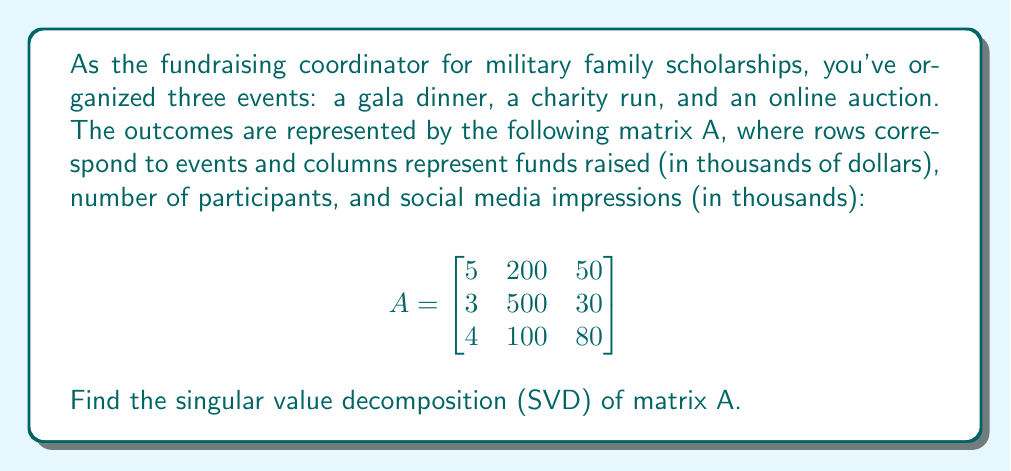Show me your answer to this math problem. To find the singular value decomposition of matrix A, we need to follow these steps:

1) First, calculate $A^TA$:

   $$A^TA = \begin{bmatrix}
   5 & 3 & 4 \\
   200 & 500 & 100 \\
   50 & 30 & 80
   \end{bmatrix} \begin{bmatrix}
   5 & 200 & 50 \\
   3 & 500 & 30 \\
   4 & 100 & 80
   \end{bmatrix} = \begin{bmatrix}
   50 & 2150 & 570 \\
   2150 & 290000 & 17000 \\
   570 & 17000 & 9100
   \end{bmatrix}$$

2) Find the eigenvalues of $A^TA$ by solving the characteristic equation:
   
   $\det(A^TA - \lambda I) = 0$

   This gives us the equation:

   $-\lambda^3 + 299150\lambda^2 - 1.30205 \times 10^9\lambda + 8.41 \times 10^{11} = 0$

3) Solving this equation (using a computer algebra system), we get the eigenvalues:
   
   $\lambda_1 \approx 290050.8$
   $\lambda_2 \approx 9098.2$
   $\lambda_3 \approx 1.0$

4) The singular values are the square roots of these eigenvalues:
   
   $\sigma_1 \approx 538.56$
   $\sigma_2 \approx 95.38$
   $\sigma_3 \approx 1.00$

5) To find the right singular vectors, we solve $(A^TA - \lambda_i I)v_i = 0$ for each $\lambda_i$. After normalization, we get:

   $v_1 \approx [0.0074, 0.9999, 0.0059]^T$
   $v_2 \approx [-0.0757, -0.0031, 0.9971]^T$
   $v_3 \approx [0.9971, -0.0075, 0.0757]^T$

6) To find the left singular vectors, we calculate $u_i = \frac{1}{\sigma_i}Av_i$ for each $i$:

   $u_1 \approx [0.3715, 0.9284, 0.0031]^T$
   $u_2 \approx [-0.4570, 0.1412, 0.8780]^T$
   $u_3 \approx [0.8089, -0.3431, 0.4780]^T$

7) The SVD of A is then given by $A = U\Sigma V^T$, where:

   $U = [u_1 \quad u_2 \quad u_3]$
   $\Sigma = \text{diag}(\sigma_1, \sigma_2, \sigma_3)$
   $V = [v_1 \quad v_2 \quad v_3]$
Answer: $A = U\Sigma V^T$, where:

$U \approx \begin{bmatrix}
0.3715 & -0.4570 & 0.8089 \\
0.9284 & 0.1412 & -0.3431 \\
0.0031 & 0.8780 & 0.4780
\end{bmatrix}$

$\Sigma \approx \begin{bmatrix}
538.56 & 0 & 0 \\
0 & 95.38 & 0 \\
0 & 0 & 1.00
\end{bmatrix}$

$V^T \approx \begin{bmatrix}
0.0074 & 0.9999 & 0.0059 \\
-0.0757 & -0.0031 & 0.9971 \\
0.9971 & -0.0075 & 0.0757
\end{bmatrix}$ 